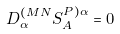<formula> <loc_0><loc_0><loc_500><loc_500>D _ { \alpha } ^ { ( M N } S ^ { P ) \alpha } _ { A } = 0</formula> 